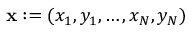<formula> <loc_0><loc_0><loc_500><loc_500>\mathbf x \colon = ( x _ { 1 } , y _ { 1 } , \dots , x _ { N } , y _ { N } )</formula> 